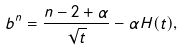Convert formula to latex. <formula><loc_0><loc_0><loc_500><loc_500>b ^ { n } = \frac { n - 2 + \alpha } { \sqrt { t } } - \alpha H ( t ) ,</formula> 